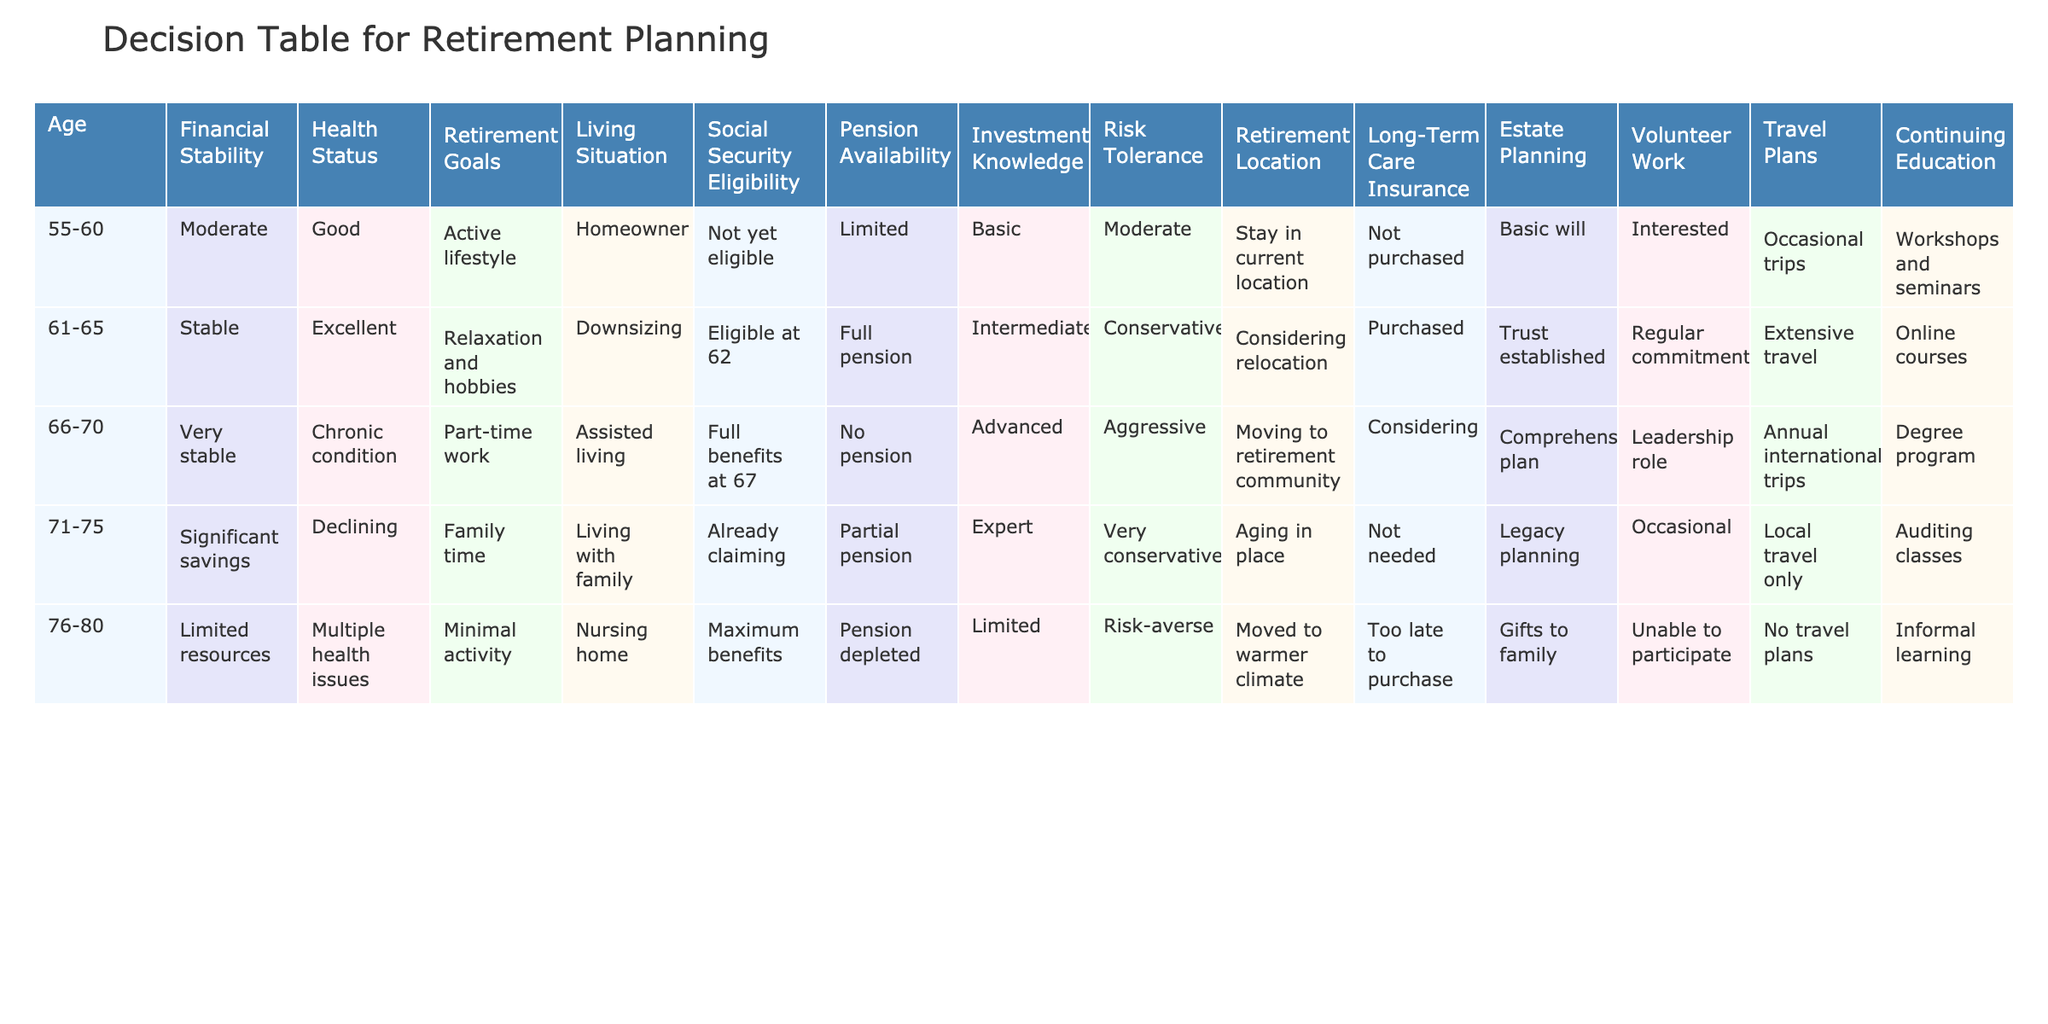What is the age range of individuals in the table? The table lists individuals in the age ranges: 55-60, 61-65, 66-70, 71-75, and 76-80.
Answer: 55-80 How many individuals have stable financial status? In the table, the individuals with stable financial status are those aged 61-65 and 66-70, which makes it a total of two individuals.
Answer: 2 Which retirement goal is most common among individuals aged 66-70? The retirement goal for the individual aged 66-70 is part-time work. This can be specifically identified in the table by checking the corresponding row for that age range.
Answer: Part-time work Is there a trend in risk tolerance as age increases? The risk tolerance values for each age group are Moderate, Conservative, Aggressive, Very conservative, and Risk-averse. As we progress through the ages, the general trend shows a decrease in risk tolerance, suggesting increased caution with age.
Answer: Yes What is the average number of travel plans for individuals aged 61-75? The travel plans for individuals aged 61-65, 66-70, and 71-75 are Extensive travel, Annual international trips, and Local travel only, respectively. To calculate the average, we assign values for travel frequency: Extensive = 3, Annual = 2, Local = 1. Adding these gives 3 + 2 + 1 = 6, and dividing by 3 gives an average of 2.
Answer: 2 Do individuals aged 76-80 typically have estate planning in place? Referring to the table, the individual aged 76-80 has 'Gifts to family' listed for estate planning, indicating that some form of planning is in place.
Answer: Yes How many individuals are in similar living situations? The living situations of individuals 55-60 (Homeowner), 61-65 (Downsizing), 66-70 (Assisted living), 71-75 (Living with family), and 76-80 (Nursing home) are all different. Therefore, there are no individuals in similar living situations.
Answer: 0 Which age group has the highest level of investment knowledge? By reviewing the investment knowledge column, the individual aged 66-70 possesses 'Advanced' investment knowledge, which is the highest level listed in the table.
Answer: 66-70 What percentage of individuals aged 71-75 have a pension? The individual aged 71-75 has a 'Partial pension.' Since there is only one individual in this age group, they constitute 100% of individuals in this category having some pension.
Answer: 100% 